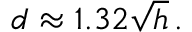<formula> <loc_0><loc_0><loc_500><loc_500>d \approx 1 . 3 2 { \sqrt { h } } \, .</formula> 